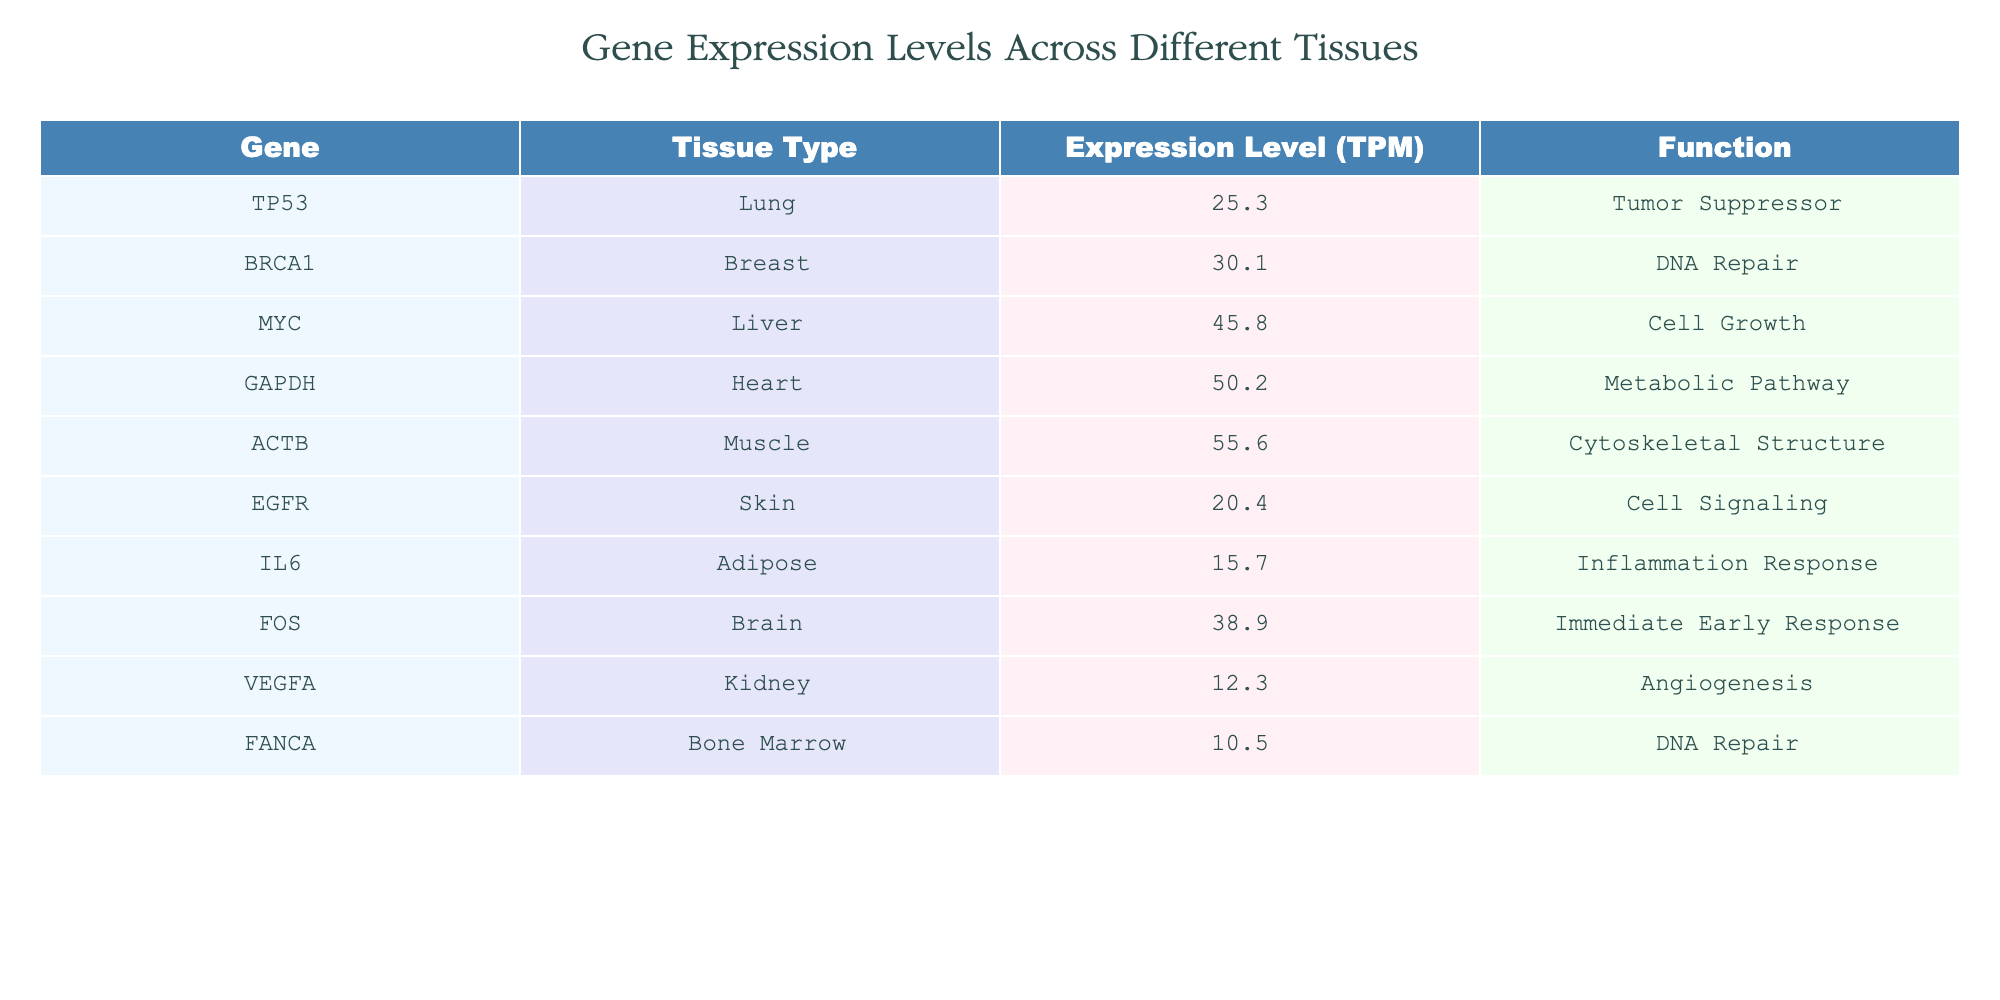What is the expression level of TP53 in the lung tissue? The table directly lists the expression levels for various genes in different tissues. Looking for TP53, we find it listed under Lung with an expression level of 25.3 TPM.
Answer: 25.3 Which gene has the highest expression level and in which tissue? By scanning through the table, we notice that ACTB in Muscle has the highest expression level of 55.6 TPM, which is higher than all the other listed values.
Answer: ACTB, Muscle What is the total expression level of genes related to DNA Repair? We look for genes with the function "DNA Repair" in the table, which are BRCA1 and FANCA. Their expression levels are 30.1 TPM (BRCA1) and 10.5 TPM (FANCA). Adding these gives us 30.1 + 10.5 = 40.6 TPM.
Answer: 40.6 Is IL6 expressed more in the Adipose tissue than EGFR in the Skin tissue? IL6 has an expression level of 15.7 TPM in Adipose, while EGFR has 20.4 TPM in Skin. Comparing these values shows that 15.7 is less than 20.4, so IL6 is not expressed more than EGFR.
Answer: No What is the average expression level of the genes listed in the Brain and Muscle tissues? The expression levels for the Brain (FOS) and Muscle (ACTB) are 38.9 TPM and 55.6 TPM, respectively. To find the average, sum these two values: 38.9 + 55.6 = 94.5, then divide by 2. The average is 94.5 / 2 = 47.25.
Answer: 47.25 